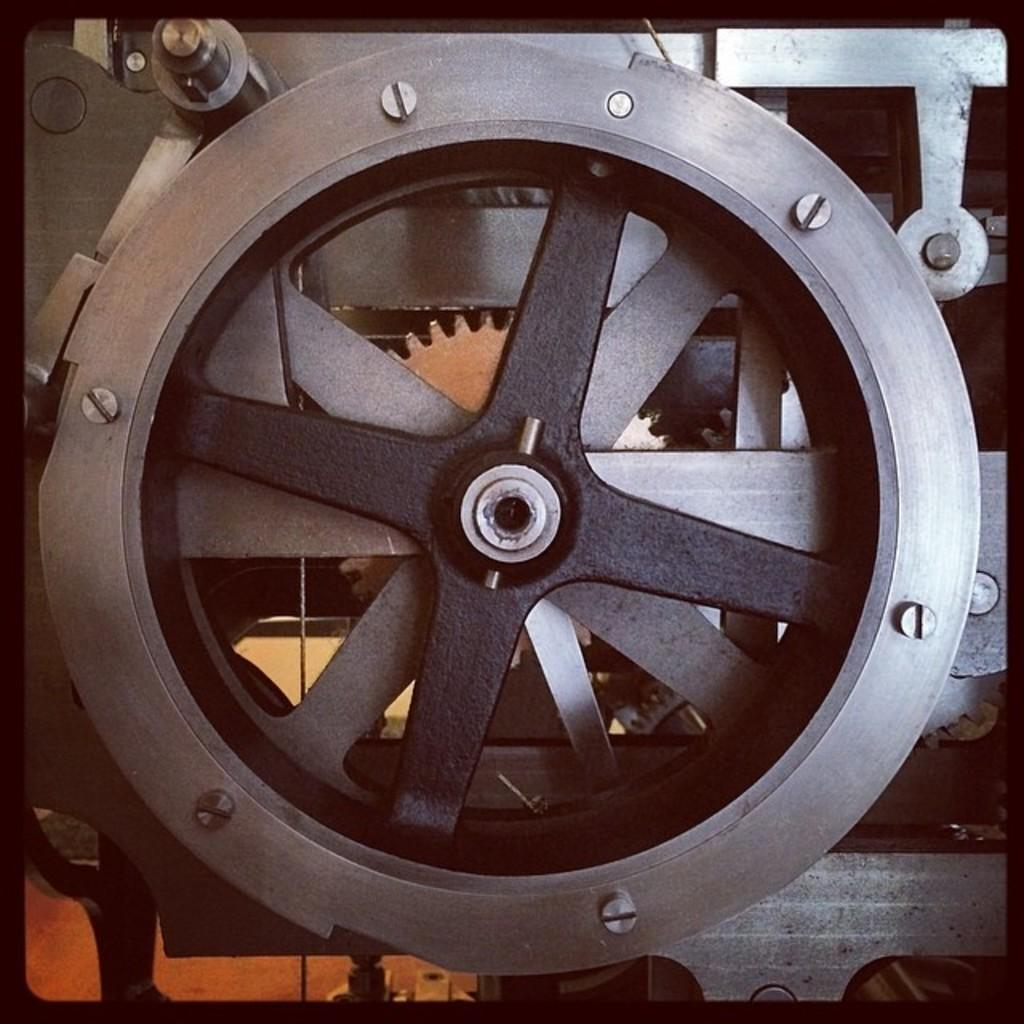What type of machine is visible in the image? There is a machine with wheels in the image. Can you describe any specific features of the machine? Yes, there are gears at the back side of the machine. What type of jewel is placed on the stream in the image? There is no jewel or stream present in the image; it only features a machine with wheels and gears. 